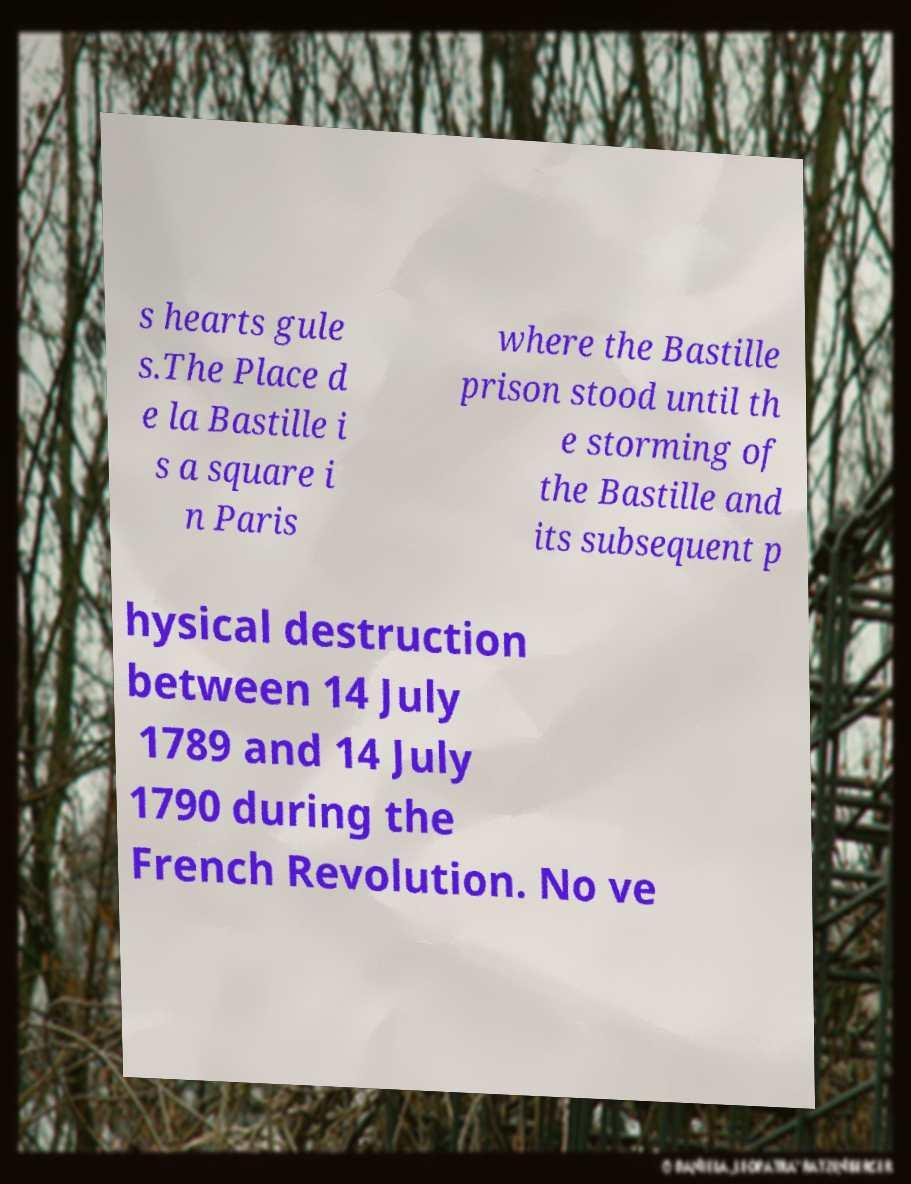For documentation purposes, I need the text within this image transcribed. Could you provide that? s hearts gule s.The Place d e la Bastille i s a square i n Paris where the Bastille prison stood until th e storming of the Bastille and its subsequent p hysical destruction between 14 July 1789 and 14 July 1790 during the French Revolution. No ve 